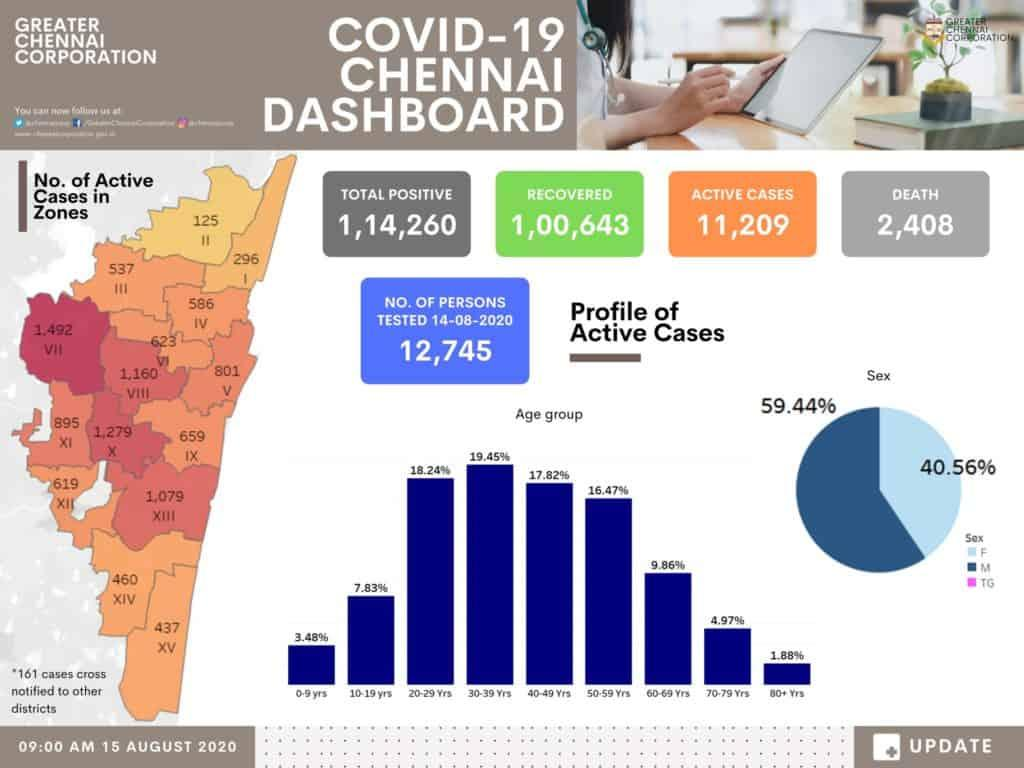Highlight a few significant elements in this photo. The study found that 16.71% of individuals above the age of 60 were impacted by the condition. The number of individuals who did not survive is 2,408. In this data set, 59.44% of men are active cases. In the group of active cases, females are over-represented, making up 40.56% of the total. 